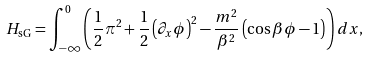<formula> <loc_0><loc_0><loc_500><loc_500>H _ { \text {sG} } = \int _ { - \infty } ^ { 0 } \left ( \frac { 1 } { 2 } \pi ^ { 2 } + \frac { 1 } { 2 } \left ( \partial _ { x } \phi \right ) ^ { 2 } - \frac { m ^ { 2 } } { \beta ^ { 2 } } \left ( \cos \beta \phi - 1 \right ) \right ) d x ,</formula> 